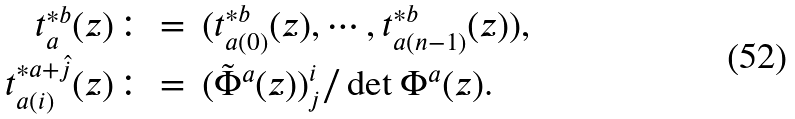Convert formula to latex. <formula><loc_0><loc_0><loc_500><loc_500>\begin{array} { r l } t _ { a } ^ { * b } ( z ) \colon = & ( t _ { a ( 0 ) } ^ { * b } ( z ) , \cdots , t _ { a ( n - 1 ) } ^ { * b } ( z ) ) , \\ t ^ { * a + \hat { j } } _ { a ( i ) } ( z ) \colon = & ( \tilde { \Phi } ^ { a } ( z ) ) _ { j } ^ { i } / \det \Phi ^ { a } ( z ) . \end{array}</formula> 